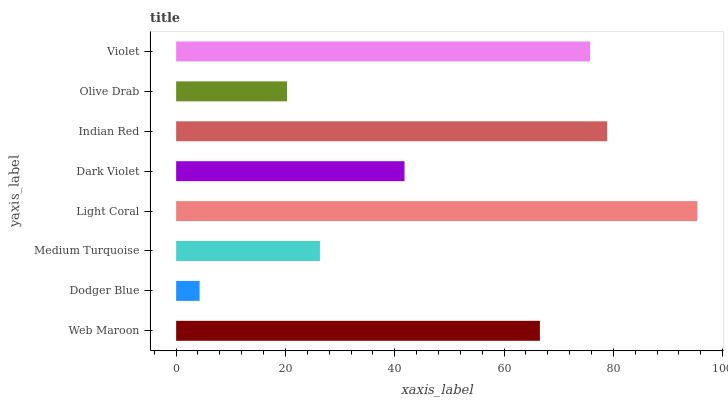Is Dodger Blue the minimum?
Answer yes or no. Yes. Is Light Coral the maximum?
Answer yes or no. Yes. Is Medium Turquoise the minimum?
Answer yes or no. No. Is Medium Turquoise the maximum?
Answer yes or no. No. Is Medium Turquoise greater than Dodger Blue?
Answer yes or no. Yes. Is Dodger Blue less than Medium Turquoise?
Answer yes or no. Yes. Is Dodger Blue greater than Medium Turquoise?
Answer yes or no. No. Is Medium Turquoise less than Dodger Blue?
Answer yes or no. No. Is Web Maroon the high median?
Answer yes or no. Yes. Is Dark Violet the low median?
Answer yes or no. Yes. Is Dark Violet the high median?
Answer yes or no. No. Is Medium Turquoise the low median?
Answer yes or no. No. 